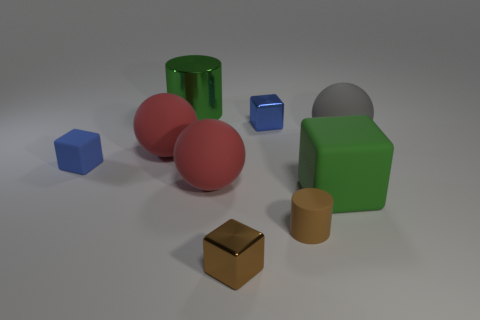What size is the green thing that is made of the same material as the big gray ball?
Your response must be concise. Large. Are there more big matte objects right of the tiny brown metal object than large rubber cubes to the left of the big green cube?
Your answer should be very brief. Yes. How many other things are made of the same material as the small brown cube?
Offer a terse response. 2. Do the large green object that is on the right side of the tiny blue metal thing and the tiny brown cube have the same material?
Provide a succinct answer. No. What is the shape of the gray object?
Give a very brief answer. Sphere. Is the number of tiny brown matte objects in front of the small blue rubber thing greater than the number of large cyan metal cubes?
Make the answer very short. Yes. There is another tiny matte thing that is the same shape as the green matte object; what color is it?
Your answer should be very brief. Blue. There is a green object on the right side of the brown rubber cylinder; what is its shape?
Offer a very short reply. Cube. Are there any small metallic cubes behind the green matte thing?
Ensure brevity in your answer.  Yes. There is another block that is the same material as the brown block; what color is it?
Offer a very short reply. Blue. 